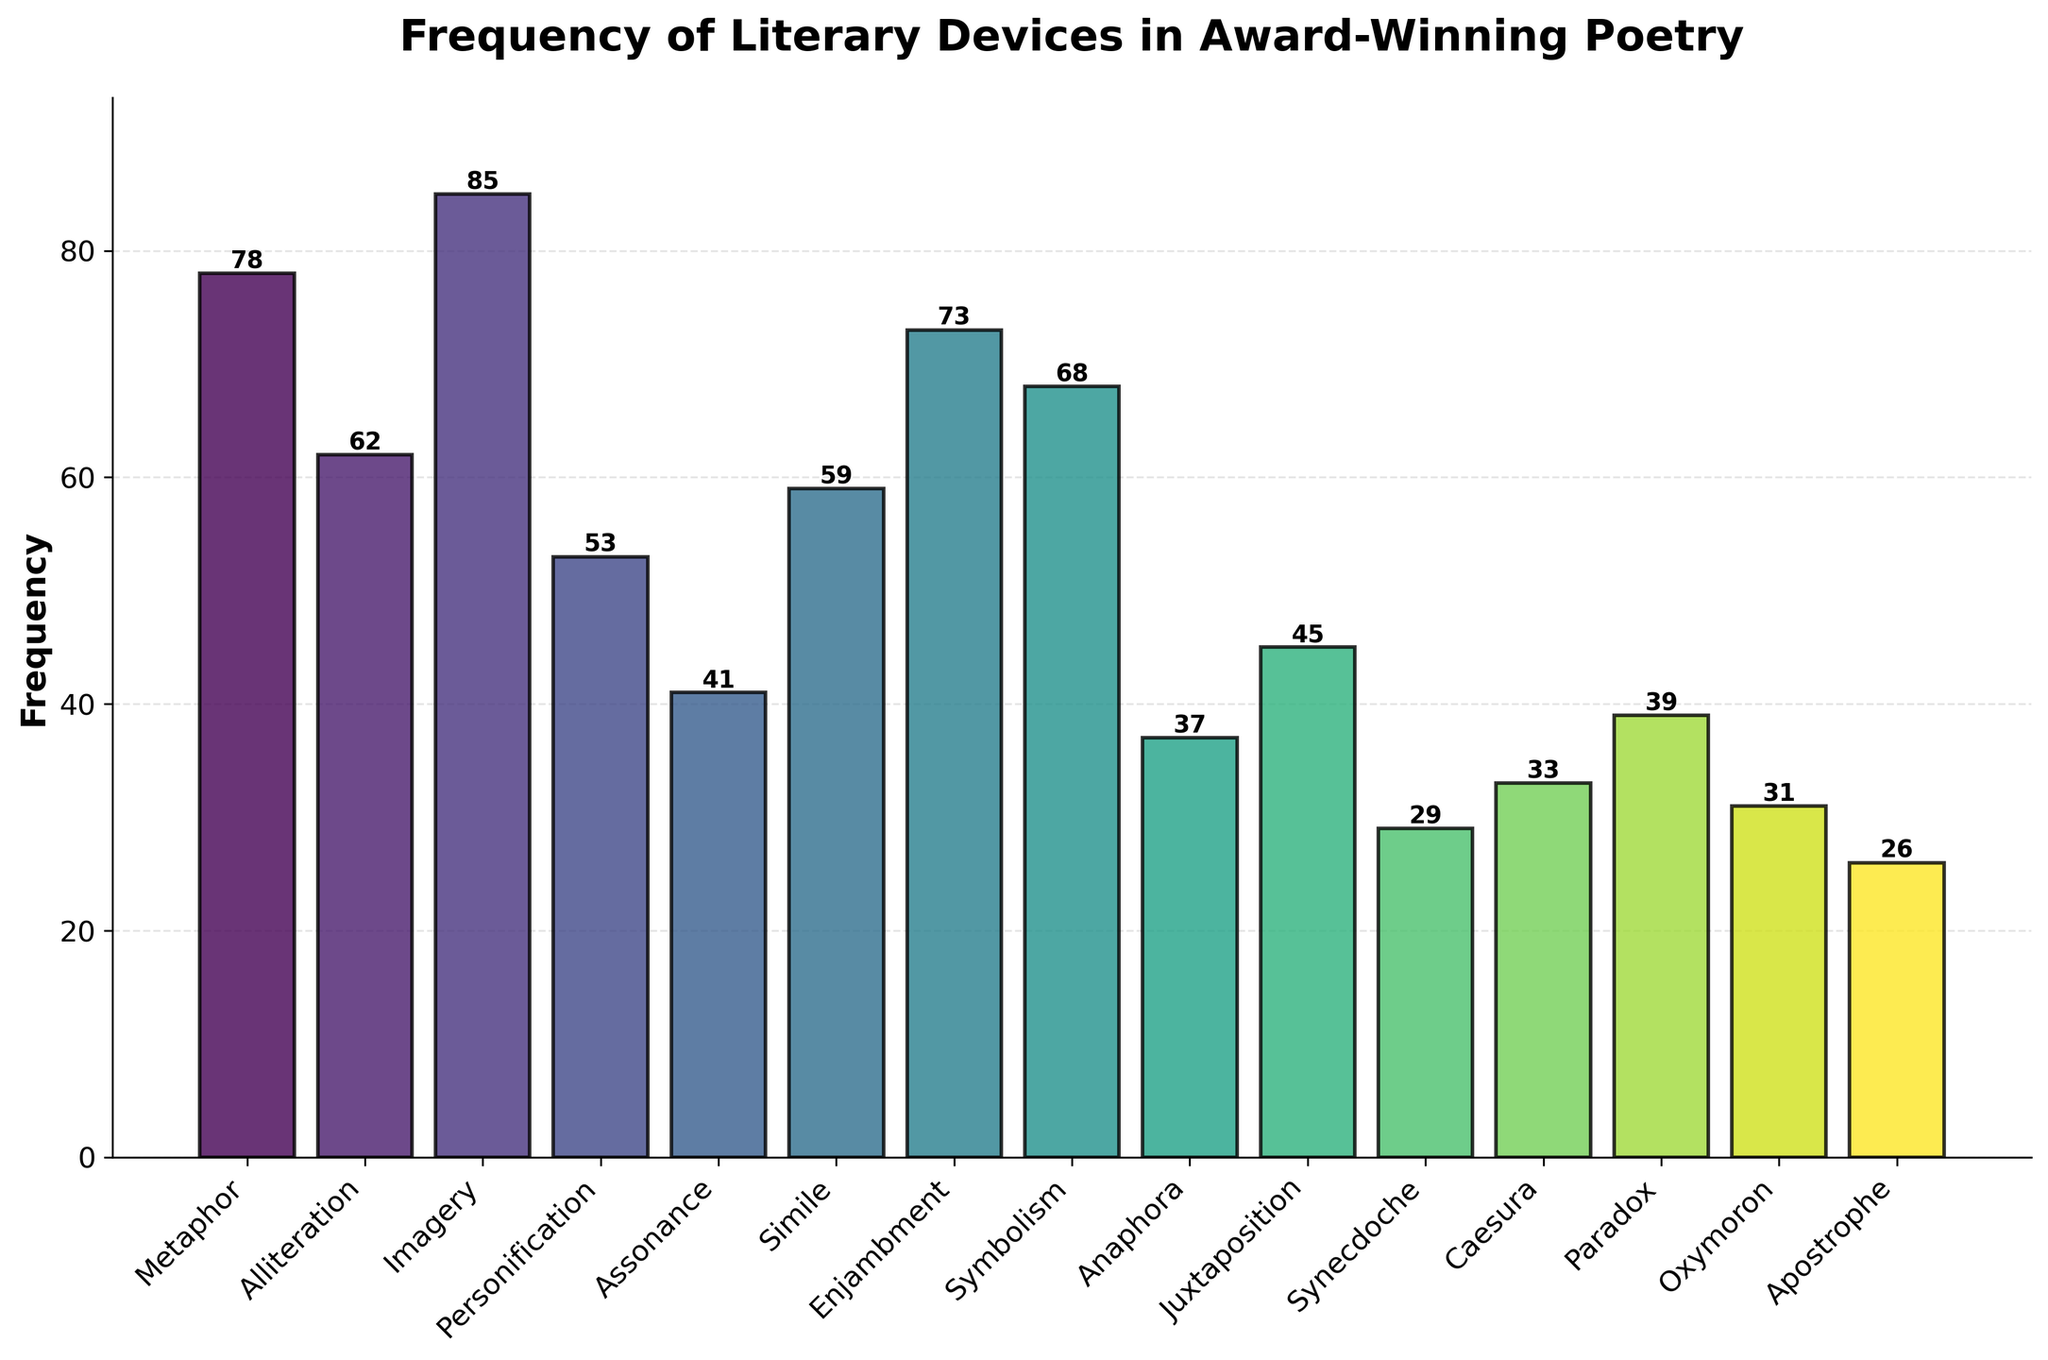What is the most frequently used literary device in award-winning poetry? To find the most frequently used literary device, look for the tallest bar in the chart. The device associated with this bar is 'Imagery' with a frequency of 85.
Answer: Imagery How many more times is 'Metaphor' used than 'Apostrophe'? Find the height of the bars corresponding to 'Metaphor' and 'Apostrophe'. 'Metaphor' has a frequency of 78 and 'Apostrophe' has a frequency of 26. Subtract 26 from 78 to get the difference.
Answer: 52 Which literary device has a lower frequency, 'Simile' or 'Symbolism'? Compare the heights of the bars for 'Simile' and 'Symbolism'. 'Simile' has a frequency of 59 and 'Symbolism' has a frequency of 68. Since 59 < 68, 'Simile' has the lower frequency.
Answer: Simile What is the combined frequency of 'Alliteration' and 'Personification'? Sum the frequencies of 'Alliteration' and 'Personification'. 'Alliteration' has a frequency of 62, and 'Personification' has a frequency of 53. So, 62 + 53 = 115.
Answer: 115 Which two literary devices have the smallest frequencies? Identify the shortest bars in the chart. The shortest bars correspond to 'Apostrophe' with a frequency of 26 and 'Synecdoche' with a frequency of 29.
Answer: Apostrophe and Synecdoche Is the frequency of 'Juxtaposition' greater than or equal to the frequency of 'Paradox'? Compare the heights of the bars for 'Juxtaposition' and 'Paradox'. 'Juxtaposition' has a frequency of 45 and 'Paradox' has a frequency of 39. Since 45 > 39, 'Juxtaposition' frequency is greater.
Answer: Yes Which literary device's frequency is closest to the average frequency of all devices? To determine this, find the average frequency first. Sum all frequencies: 78 (Metaphor) + 62 (Alliteration) + 85 (Imagery) + 53 (Personification) + 41 (Assonance) + 59 (Simile) + 73 (Enjambment) + 68 (Symbolism) + 37 (Anaphora) + 45 (Juxtaposition) + 29 (Synecdoche) + 33 (Caesura) + 39 (Paradox) + 31 (Oxymoron) + 26 (Apostrophe) = 759. Divide by the number of devices (15): 759 / 15 = 50.6. The frequency closest to 50.6 is 'Personification' with a frequency of 53.
Answer: Personification What is the median frequency value of the literary devices? To find the median frequency, list all frequencies in ascending order: 26, 29, 31, 33, 37, 39, 41, 45, 53, 59, 62, 68, 73, 78, 85. The middle value (8th value) in this ordered list is 45 (Juxtaposition).
Answer: 45 